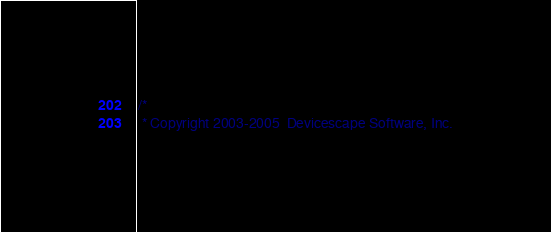Convert code to text. <code><loc_0><loc_0><loc_500><loc_500><_C_>/*
 * Copyright 2003-2005	Devicescape Software, Inc.</code> 